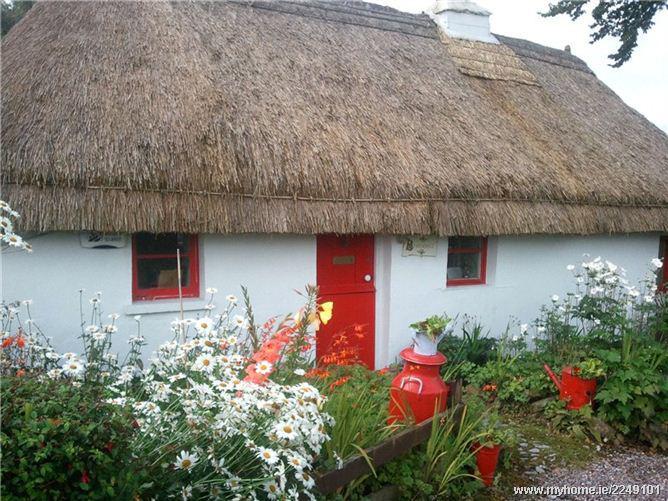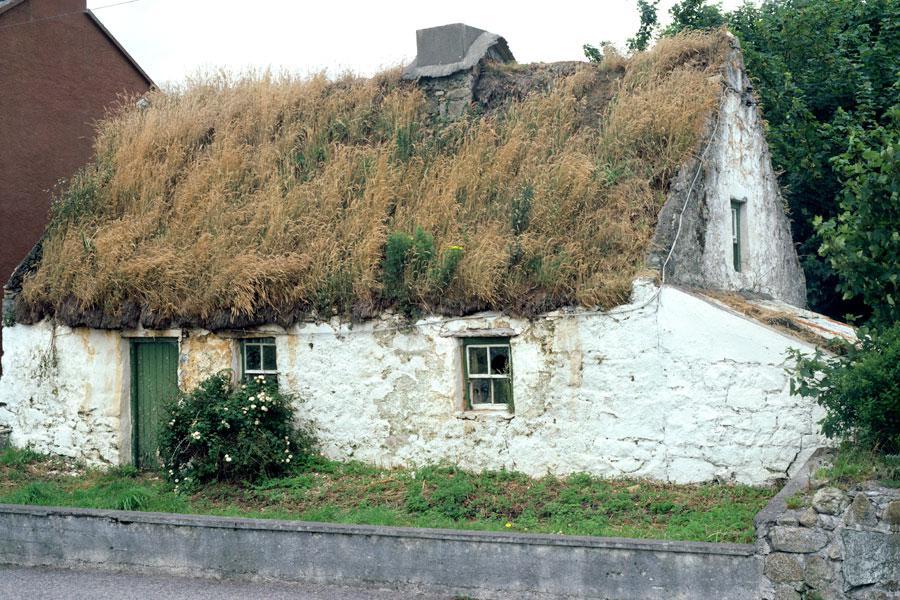The first image is the image on the left, the second image is the image on the right. Examine the images to the left and right. Is the description "In at least one image there is a cream colored house with black stripes of wood that create a box look." accurate? Answer yes or no. No. The first image is the image on the left, the second image is the image on the right. Analyze the images presented: Is the assertion "The left image shows a white house with bold dark lines on it forming geometric patterns, and a thatched roof with at least one notched cut-out for windows, and the right image shows a house with a thatched roof over the door and a roof over the house itself." valid? Answer yes or no. No. 